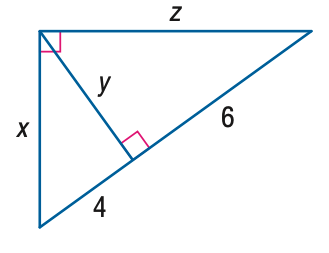Answer the mathemtical geometry problem and directly provide the correct option letter.
Question: Find x.
Choices: A: 4 B: 2 \sqrt { 5 } C: 2 \sqrt { 6 } D: 2 \sqrt { 10 } D 